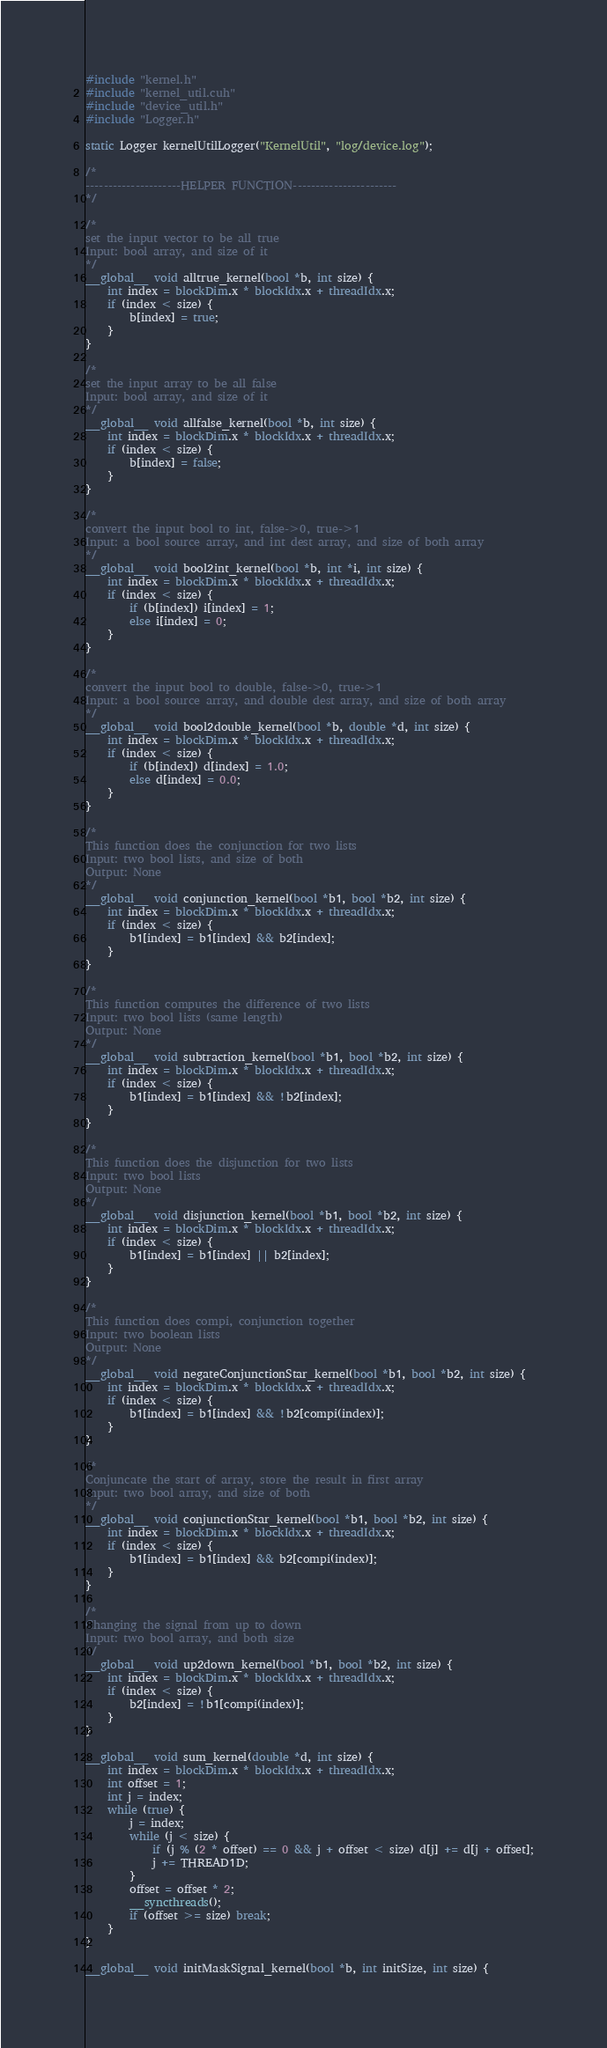<code> <loc_0><loc_0><loc_500><loc_500><_Cuda_>#include "kernel.h"
#include "kernel_util.cuh"
#include "device_util.h"
#include "Logger.h"

static Logger kernelUtilLogger("KernelUtil", "log/device.log");

/*
---------------------HELPER FUNCTION-----------------------
*/

/*
set the input vector to be all true
Input: bool array, and size of it
*/
__global__ void alltrue_kernel(bool *b, int size) {
	int index = blockDim.x * blockIdx.x + threadIdx.x;
	if (index < size) {
		b[index] = true;
	}
}

/*
set the input array to be all false
Input: bool array, and size of it
*/
__global__ void allfalse_kernel(bool *b, int size) {
	int index = blockDim.x * blockIdx.x + threadIdx.x;
	if (index < size) {
		b[index] = false;
	}
}

/*
convert the input bool to int, false->0, true->1
Input: a bool source array, and int dest array, and size of both array
*/
__global__ void bool2int_kernel(bool *b, int *i, int size) {
	int index = blockDim.x * blockIdx.x + threadIdx.x;
	if (index < size) {
		if (b[index]) i[index] = 1;
		else i[index] = 0;
	}
}

/*
convert the input bool to double, false->0, true->1
Input: a bool source array, and double dest array, and size of both array
*/
__global__ void bool2double_kernel(bool *b, double *d, int size) {
	int index = blockDim.x * blockIdx.x + threadIdx.x;
	if (index < size) {
		if (b[index]) d[index] = 1.0;
		else d[index] = 0.0;
	}
}

/*
This function does the conjunction for two lists
Input: two bool lists, and size of both
Output: None
*/
__global__ void conjunction_kernel(bool *b1, bool *b2, int size) {
	int index = blockDim.x * blockIdx.x + threadIdx.x;
	if (index < size) {
		b1[index] = b1[index] && b2[index];
	}
}

/*
This function computes the difference of two lists
Input: two bool lists (same length)
Output: None
*/
__global__ void subtraction_kernel(bool *b1, bool *b2, int size) {
	int index = blockDim.x * blockIdx.x + threadIdx.x;
	if (index < size) {
		b1[index] = b1[index] && !b2[index];
	}
}

/*
This function does the disjunction for two lists
Input: two bool lists
Output: None
*/
__global__ void disjunction_kernel(bool *b1, bool *b2, int size) {
	int index = blockDim.x * blockIdx.x + threadIdx.x;
	if (index < size) {
		b1[index] = b1[index] || b2[index];
	}
}

/*
This function does compi, conjunction together
Input: two boolean lists
Output: None
*/
__global__ void negateConjunctionStar_kernel(bool *b1, bool *b2, int size) {
	int index = blockDim.x * blockIdx.x + threadIdx.x;
	if (index < size) {
		b1[index] = b1[index] && !b2[compi(index)];
	}
}

/*
Conjuncate the start of array, store the result in first array
Input: two bool array, and size of both
*/
__global__ void conjunctionStar_kernel(bool *b1, bool *b2, int size) {
	int index = blockDim.x * blockIdx.x + threadIdx.x;
	if (index < size) {
		b1[index] = b1[index] && b2[compi(index)];
	}
}

/*
Changing the signal from up to down
Input: two bool array, and both size
*/
__global__ void up2down_kernel(bool *b1, bool *b2, int size) {
	int index = blockDim.x * blockIdx.x + threadIdx.x;
	if (index < size) {
		b2[index] = !b1[compi(index)];
	}
}

__global__ void sum_kernel(double *d, int size) {
	int index = blockDim.x * blockIdx.x + threadIdx.x;
	int offset = 1;
	int j = index;
	while (true) {
		j = index;
		while (j < size) {
			if (j % (2 * offset) == 0 && j + offset < size) d[j] += d[j + offset];
			j += THREAD1D;
		}
		offset = offset * 2;
		__syncthreads();
		if (offset >= size) break;
	}
}

__global__ void initMaskSignal_kernel(bool *b, int initSize, int size) {</code> 